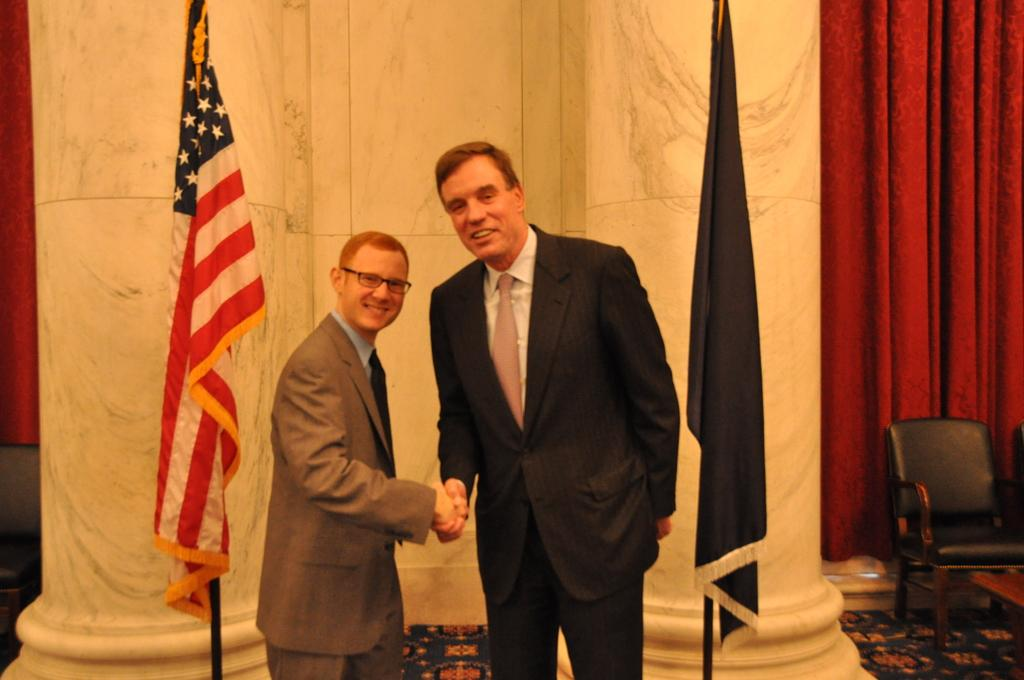How many people are in the image? A: There are two men in the image. What is the facial expression of the men in the image? The men are smiling. What can be seen in the background of the image? There are two flags and a white wall in the background of the image. What type of riddle is the man on the left side of the image telling? There is no indication in the image that a riddle is being told, so it cannot be determined from the picture. 